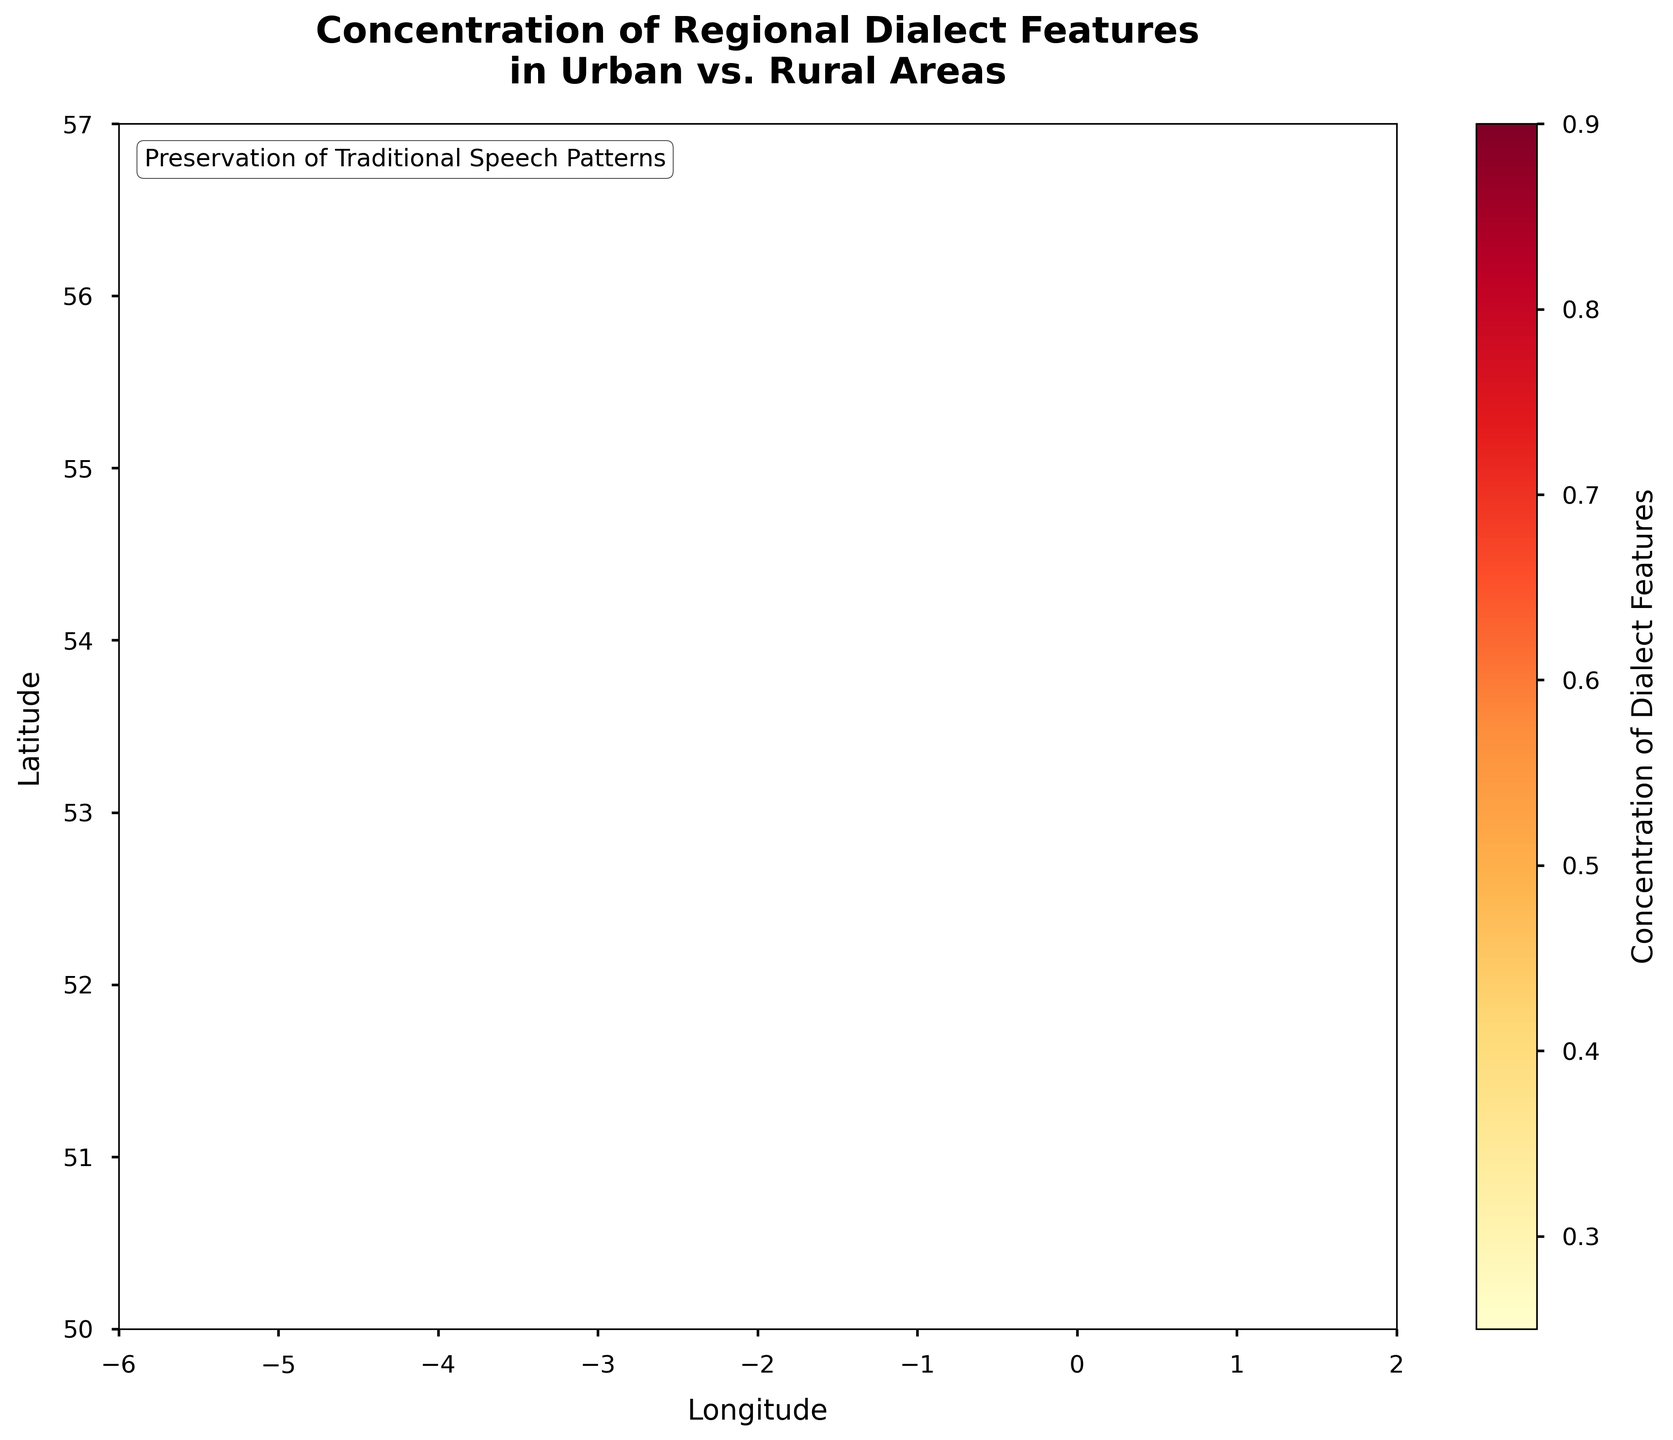What is the title of the plot? The title of the plot is located at the top and it reads 'Concentration of Regional Dialect Features in Urban vs. Rural Areas'.
Answer: 'Concentration of Regional Dialect Features in Urban vs. Rural Areas' Which axis represents latitude? The y-axis represents latitude as indicated by the axis label 'Latitude' on the vertical axis of the plot.
Answer: y-axis What color indicates the highest concentration of dialect features? The color with the highest concentration is the one at the top of the color bar, which appears to be a dark red.
Answer: Dark red What are the approximate longitude and latitude boundaries of the plot? The x-axis (longitude) ranges from about -6 to 2, and the y-axis (latitude) ranges from about 50 to 57.
Answer: Longitude: -6 to 2, Latitude: 50 to 57 What feature does the color bar label represent? The color bar label represents the 'Concentration of Dialect Features'.
Answer: Concentration of Dialect Features What is the caption located inside the plot? The caption inside the plot reads 'Preservation of Traditional Speech Patterns'.
Answer: 'Preservation of Traditional Speech Patterns' Do urban or rural areas tend to have higher concentrations of dialect features? The plot should be interpreted to see whether hexagons with darker colors are located typically in urban or rural coordinates. The darker hexagons, indicating higher concentrations, are mostly in regions that are geographically near major urban areas.
Answer: Urban areas In which region(s) do we see the highest concentration (darkest hexagons)? The highest concentration regions, marked by the darkest hexagons, are situated around latitudes and longitudes approximately corresponding to Northern England and parts of Scotland.
Answer: Northern England and Scotland What is the concentration range represented in the color bar? The color bar represents a range of concentrations from a lighter color representing low concentration to dark red representing high concentration, typically values ranging from low to high.
Answer: Low to high Is there a visible trend in the concentration of dialect features relative to latitude? By examining the distribution of colors along the y-axis (latitude), we can infer whether there's a trend. The plot shows that higher concentrations tend to appear at higher latitudes, indicating a potential trend.
Answer: Yes, higher at higher latitudes 